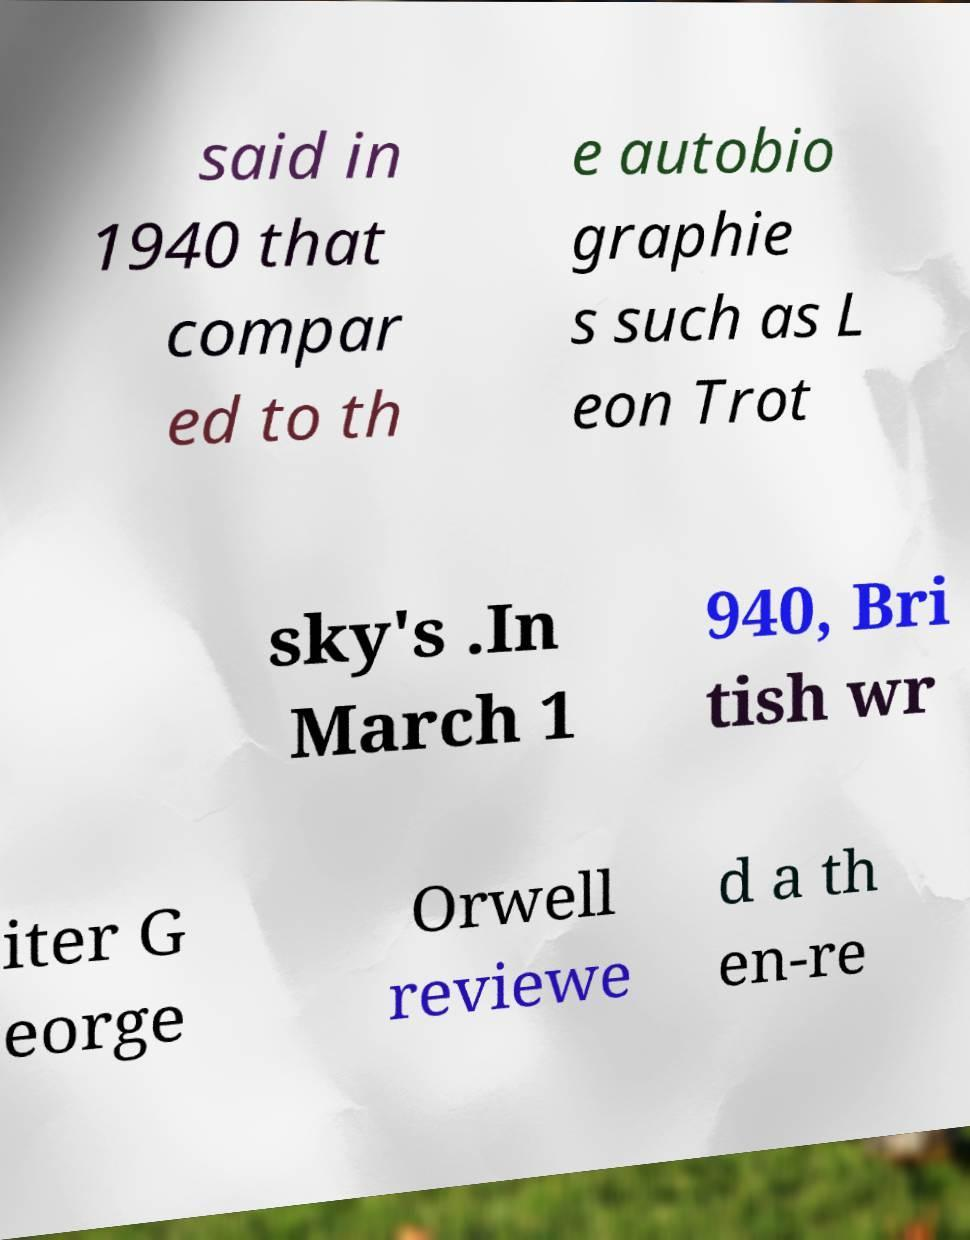There's text embedded in this image that I need extracted. Can you transcribe it verbatim? said in 1940 that compar ed to th e autobio graphie s such as L eon Trot sky's .In March 1 940, Bri tish wr iter G eorge Orwell reviewe d a th en-re 